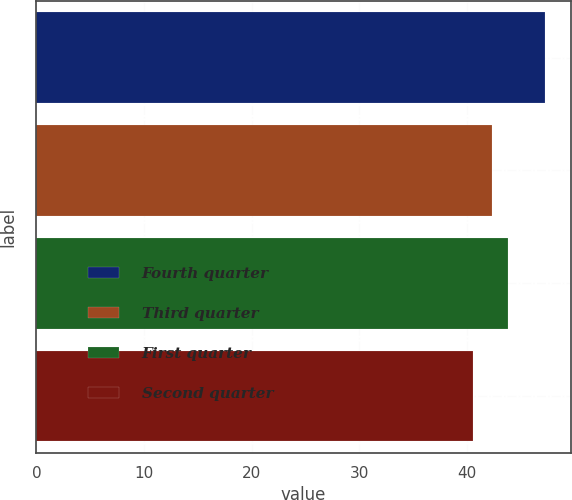<chart> <loc_0><loc_0><loc_500><loc_500><bar_chart><fcel>Fourth quarter<fcel>Third quarter<fcel>First quarter<fcel>Second quarter<nl><fcel>47.26<fcel>42.32<fcel>43.83<fcel>40.52<nl></chart> 